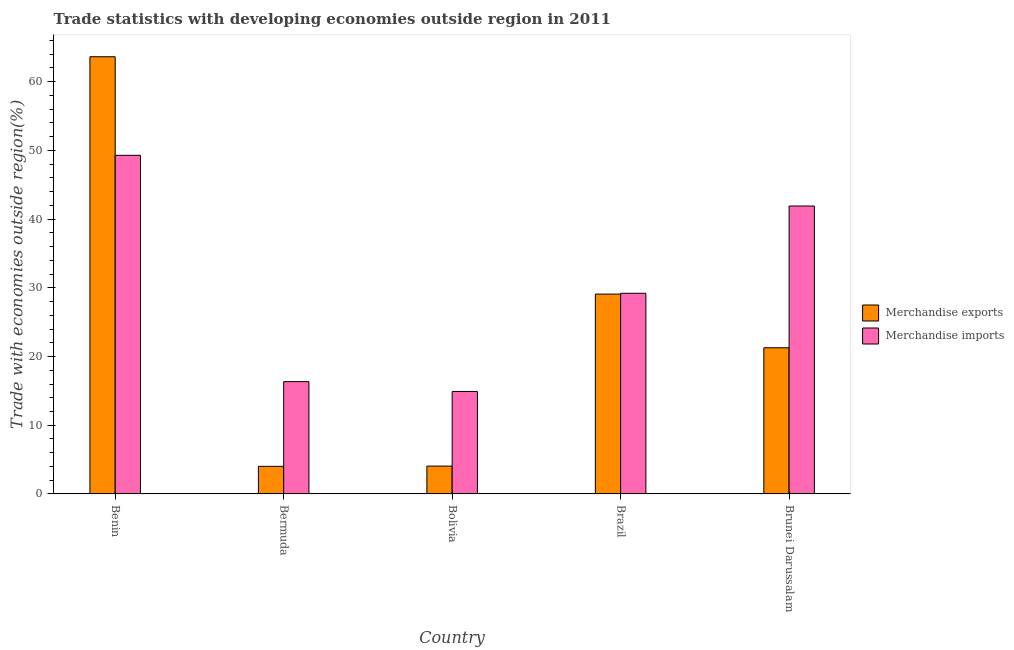How many different coloured bars are there?
Give a very brief answer. 2. Are the number of bars on each tick of the X-axis equal?
Your answer should be compact. Yes. How many bars are there on the 5th tick from the left?
Your answer should be compact. 2. What is the merchandise exports in Bermuda?
Provide a short and direct response. 4.02. Across all countries, what is the maximum merchandise imports?
Provide a short and direct response. 49.27. Across all countries, what is the minimum merchandise imports?
Provide a succinct answer. 14.91. In which country was the merchandise exports maximum?
Provide a succinct answer. Benin. In which country was the merchandise exports minimum?
Keep it short and to the point. Bermuda. What is the total merchandise imports in the graph?
Make the answer very short. 151.63. What is the difference between the merchandise exports in Benin and that in Brunei Darussalam?
Make the answer very short. 42.35. What is the difference between the merchandise exports in Brunei Darussalam and the merchandise imports in Benin?
Give a very brief answer. -28. What is the average merchandise imports per country?
Your response must be concise. 30.33. What is the difference between the merchandise imports and merchandise exports in Brunei Darussalam?
Your answer should be very brief. 20.62. What is the ratio of the merchandise imports in Bermuda to that in Brazil?
Offer a terse response. 0.56. Is the merchandise exports in Benin less than that in Bermuda?
Offer a very short reply. No. Is the difference between the merchandise exports in Benin and Brazil greater than the difference between the merchandise imports in Benin and Brazil?
Your response must be concise. Yes. What is the difference between the highest and the second highest merchandise imports?
Keep it short and to the point. 7.38. What is the difference between the highest and the lowest merchandise exports?
Keep it short and to the point. 59.6. In how many countries, is the merchandise exports greater than the average merchandise exports taken over all countries?
Your answer should be compact. 2. Is the sum of the merchandise exports in Bermuda and Brazil greater than the maximum merchandise imports across all countries?
Make the answer very short. No. How many bars are there?
Your answer should be very brief. 10. How many countries are there in the graph?
Make the answer very short. 5. Does the graph contain any zero values?
Offer a terse response. No. Does the graph contain grids?
Provide a short and direct response. No. Where does the legend appear in the graph?
Offer a terse response. Center right. How many legend labels are there?
Keep it short and to the point. 2. What is the title of the graph?
Provide a succinct answer. Trade statistics with developing economies outside region in 2011. Does "Merchandise imports" appear as one of the legend labels in the graph?
Your response must be concise. Yes. What is the label or title of the X-axis?
Offer a very short reply. Country. What is the label or title of the Y-axis?
Provide a short and direct response. Trade with economies outside region(%). What is the Trade with economies outside region(%) in Merchandise exports in Benin?
Provide a short and direct response. 63.62. What is the Trade with economies outside region(%) in Merchandise imports in Benin?
Your answer should be compact. 49.27. What is the Trade with economies outside region(%) in Merchandise exports in Bermuda?
Provide a short and direct response. 4.02. What is the Trade with economies outside region(%) of Merchandise imports in Bermuda?
Your response must be concise. 16.35. What is the Trade with economies outside region(%) in Merchandise exports in Bolivia?
Your answer should be very brief. 4.05. What is the Trade with economies outside region(%) of Merchandise imports in Bolivia?
Give a very brief answer. 14.91. What is the Trade with economies outside region(%) of Merchandise exports in Brazil?
Your response must be concise. 29.08. What is the Trade with economies outside region(%) of Merchandise imports in Brazil?
Give a very brief answer. 29.2. What is the Trade with economies outside region(%) in Merchandise exports in Brunei Darussalam?
Offer a terse response. 21.27. What is the Trade with economies outside region(%) in Merchandise imports in Brunei Darussalam?
Offer a very short reply. 41.9. Across all countries, what is the maximum Trade with economies outside region(%) in Merchandise exports?
Your answer should be compact. 63.62. Across all countries, what is the maximum Trade with economies outside region(%) of Merchandise imports?
Give a very brief answer. 49.27. Across all countries, what is the minimum Trade with economies outside region(%) in Merchandise exports?
Your answer should be compact. 4.02. Across all countries, what is the minimum Trade with economies outside region(%) in Merchandise imports?
Keep it short and to the point. 14.91. What is the total Trade with economies outside region(%) in Merchandise exports in the graph?
Provide a short and direct response. 122.05. What is the total Trade with economies outside region(%) in Merchandise imports in the graph?
Provide a succinct answer. 151.63. What is the difference between the Trade with economies outside region(%) in Merchandise exports in Benin and that in Bermuda?
Your response must be concise. 59.6. What is the difference between the Trade with economies outside region(%) of Merchandise imports in Benin and that in Bermuda?
Your response must be concise. 32.93. What is the difference between the Trade with economies outside region(%) of Merchandise exports in Benin and that in Bolivia?
Keep it short and to the point. 59.56. What is the difference between the Trade with economies outside region(%) of Merchandise imports in Benin and that in Bolivia?
Keep it short and to the point. 34.36. What is the difference between the Trade with economies outside region(%) of Merchandise exports in Benin and that in Brazil?
Your response must be concise. 34.54. What is the difference between the Trade with economies outside region(%) of Merchandise imports in Benin and that in Brazil?
Offer a very short reply. 20.07. What is the difference between the Trade with economies outside region(%) of Merchandise exports in Benin and that in Brunei Darussalam?
Provide a succinct answer. 42.35. What is the difference between the Trade with economies outside region(%) of Merchandise imports in Benin and that in Brunei Darussalam?
Your answer should be very brief. 7.38. What is the difference between the Trade with economies outside region(%) in Merchandise exports in Bermuda and that in Bolivia?
Your answer should be very brief. -0.03. What is the difference between the Trade with economies outside region(%) in Merchandise imports in Bermuda and that in Bolivia?
Your answer should be compact. 1.43. What is the difference between the Trade with economies outside region(%) in Merchandise exports in Bermuda and that in Brazil?
Your response must be concise. -25.06. What is the difference between the Trade with economies outside region(%) in Merchandise imports in Bermuda and that in Brazil?
Offer a very short reply. -12.86. What is the difference between the Trade with economies outside region(%) of Merchandise exports in Bermuda and that in Brunei Darussalam?
Keep it short and to the point. -17.25. What is the difference between the Trade with economies outside region(%) of Merchandise imports in Bermuda and that in Brunei Darussalam?
Provide a succinct answer. -25.55. What is the difference between the Trade with economies outside region(%) of Merchandise exports in Bolivia and that in Brazil?
Keep it short and to the point. -25.03. What is the difference between the Trade with economies outside region(%) in Merchandise imports in Bolivia and that in Brazil?
Your answer should be compact. -14.29. What is the difference between the Trade with economies outside region(%) of Merchandise exports in Bolivia and that in Brunei Darussalam?
Your response must be concise. -17.22. What is the difference between the Trade with economies outside region(%) of Merchandise imports in Bolivia and that in Brunei Darussalam?
Provide a succinct answer. -26.98. What is the difference between the Trade with economies outside region(%) in Merchandise exports in Brazil and that in Brunei Darussalam?
Offer a very short reply. 7.81. What is the difference between the Trade with economies outside region(%) of Merchandise imports in Brazil and that in Brunei Darussalam?
Your answer should be compact. -12.7. What is the difference between the Trade with economies outside region(%) in Merchandise exports in Benin and the Trade with economies outside region(%) in Merchandise imports in Bermuda?
Your answer should be very brief. 47.27. What is the difference between the Trade with economies outside region(%) in Merchandise exports in Benin and the Trade with economies outside region(%) in Merchandise imports in Bolivia?
Make the answer very short. 48.7. What is the difference between the Trade with economies outside region(%) of Merchandise exports in Benin and the Trade with economies outside region(%) of Merchandise imports in Brazil?
Offer a very short reply. 34.42. What is the difference between the Trade with economies outside region(%) of Merchandise exports in Benin and the Trade with economies outside region(%) of Merchandise imports in Brunei Darussalam?
Give a very brief answer. 21.72. What is the difference between the Trade with economies outside region(%) in Merchandise exports in Bermuda and the Trade with economies outside region(%) in Merchandise imports in Bolivia?
Your answer should be compact. -10.89. What is the difference between the Trade with economies outside region(%) of Merchandise exports in Bermuda and the Trade with economies outside region(%) of Merchandise imports in Brazil?
Offer a terse response. -25.18. What is the difference between the Trade with economies outside region(%) in Merchandise exports in Bermuda and the Trade with economies outside region(%) in Merchandise imports in Brunei Darussalam?
Provide a succinct answer. -37.88. What is the difference between the Trade with economies outside region(%) of Merchandise exports in Bolivia and the Trade with economies outside region(%) of Merchandise imports in Brazil?
Offer a terse response. -25.15. What is the difference between the Trade with economies outside region(%) in Merchandise exports in Bolivia and the Trade with economies outside region(%) in Merchandise imports in Brunei Darussalam?
Ensure brevity in your answer.  -37.84. What is the difference between the Trade with economies outside region(%) of Merchandise exports in Brazil and the Trade with economies outside region(%) of Merchandise imports in Brunei Darussalam?
Make the answer very short. -12.82. What is the average Trade with economies outside region(%) in Merchandise exports per country?
Offer a terse response. 24.41. What is the average Trade with economies outside region(%) of Merchandise imports per country?
Give a very brief answer. 30.33. What is the difference between the Trade with economies outside region(%) in Merchandise exports and Trade with economies outside region(%) in Merchandise imports in Benin?
Your answer should be compact. 14.34. What is the difference between the Trade with economies outside region(%) in Merchandise exports and Trade with economies outside region(%) in Merchandise imports in Bermuda?
Give a very brief answer. -12.32. What is the difference between the Trade with economies outside region(%) in Merchandise exports and Trade with economies outside region(%) in Merchandise imports in Bolivia?
Offer a very short reply. -10.86. What is the difference between the Trade with economies outside region(%) of Merchandise exports and Trade with economies outside region(%) of Merchandise imports in Brazil?
Your answer should be compact. -0.12. What is the difference between the Trade with economies outside region(%) of Merchandise exports and Trade with economies outside region(%) of Merchandise imports in Brunei Darussalam?
Offer a very short reply. -20.62. What is the ratio of the Trade with economies outside region(%) in Merchandise exports in Benin to that in Bermuda?
Make the answer very short. 15.82. What is the ratio of the Trade with economies outside region(%) in Merchandise imports in Benin to that in Bermuda?
Give a very brief answer. 3.01. What is the ratio of the Trade with economies outside region(%) of Merchandise exports in Benin to that in Bolivia?
Ensure brevity in your answer.  15.69. What is the ratio of the Trade with economies outside region(%) in Merchandise imports in Benin to that in Bolivia?
Keep it short and to the point. 3.3. What is the ratio of the Trade with economies outside region(%) in Merchandise exports in Benin to that in Brazil?
Make the answer very short. 2.19. What is the ratio of the Trade with economies outside region(%) of Merchandise imports in Benin to that in Brazil?
Your answer should be compact. 1.69. What is the ratio of the Trade with economies outside region(%) of Merchandise exports in Benin to that in Brunei Darussalam?
Your answer should be compact. 2.99. What is the ratio of the Trade with economies outside region(%) in Merchandise imports in Benin to that in Brunei Darussalam?
Provide a succinct answer. 1.18. What is the ratio of the Trade with economies outside region(%) of Merchandise exports in Bermuda to that in Bolivia?
Your response must be concise. 0.99. What is the ratio of the Trade with economies outside region(%) in Merchandise imports in Bermuda to that in Bolivia?
Your answer should be very brief. 1.1. What is the ratio of the Trade with economies outside region(%) in Merchandise exports in Bermuda to that in Brazil?
Offer a very short reply. 0.14. What is the ratio of the Trade with economies outside region(%) of Merchandise imports in Bermuda to that in Brazil?
Give a very brief answer. 0.56. What is the ratio of the Trade with economies outside region(%) of Merchandise exports in Bermuda to that in Brunei Darussalam?
Give a very brief answer. 0.19. What is the ratio of the Trade with economies outside region(%) in Merchandise imports in Bermuda to that in Brunei Darussalam?
Your answer should be very brief. 0.39. What is the ratio of the Trade with economies outside region(%) of Merchandise exports in Bolivia to that in Brazil?
Provide a short and direct response. 0.14. What is the ratio of the Trade with economies outside region(%) in Merchandise imports in Bolivia to that in Brazil?
Your response must be concise. 0.51. What is the ratio of the Trade with economies outside region(%) in Merchandise exports in Bolivia to that in Brunei Darussalam?
Provide a short and direct response. 0.19. What is the ratio of the Trade with economies outside region(%) in Merchandise imports in Bolivia to that in Brunei Darussalam?
Your answer should be very brief. 0.36. What is the ratio of the Trade with economies outside region(%) of Merchandise exports in Brazil to that in Brunei Darussalam?
Provide a short and direct response. 1.37. What is the ratio of the Trade with economies outside region(%) of Merchandise imports in Brazil to that in Brunei Darussalam?
Offer a very short reply. 0.7. What is the difference between the highest and the second highest Trade with economies outside region(%) in Merchandise exports?
Ensure brevity in your answer.  34.54. What is the difference between the highest and the second highest Trade with economies outside region(%) in Merchandise imports?
Ensure brevity in your answer.  7.38. What is the difference between the highest and the lowest Trade with economies outside region(%) in Merchandise exports?
Make the answer very short. 59.6. What is the difference between the highest and the lowest Trade with economies outside region(%) in Merchandise imports?
Offer a terse response. 34.36. 